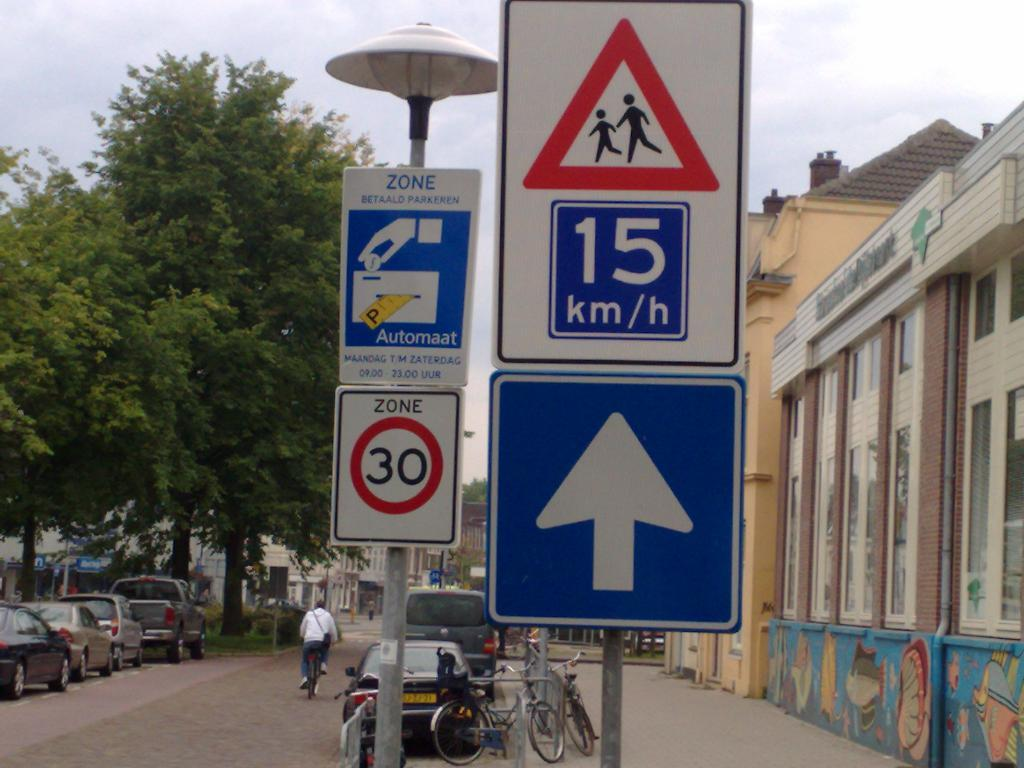Provide a one-sentence caption for the provided image. The speed in zone 30 is 15 km/h but be careful for pedestrians. 